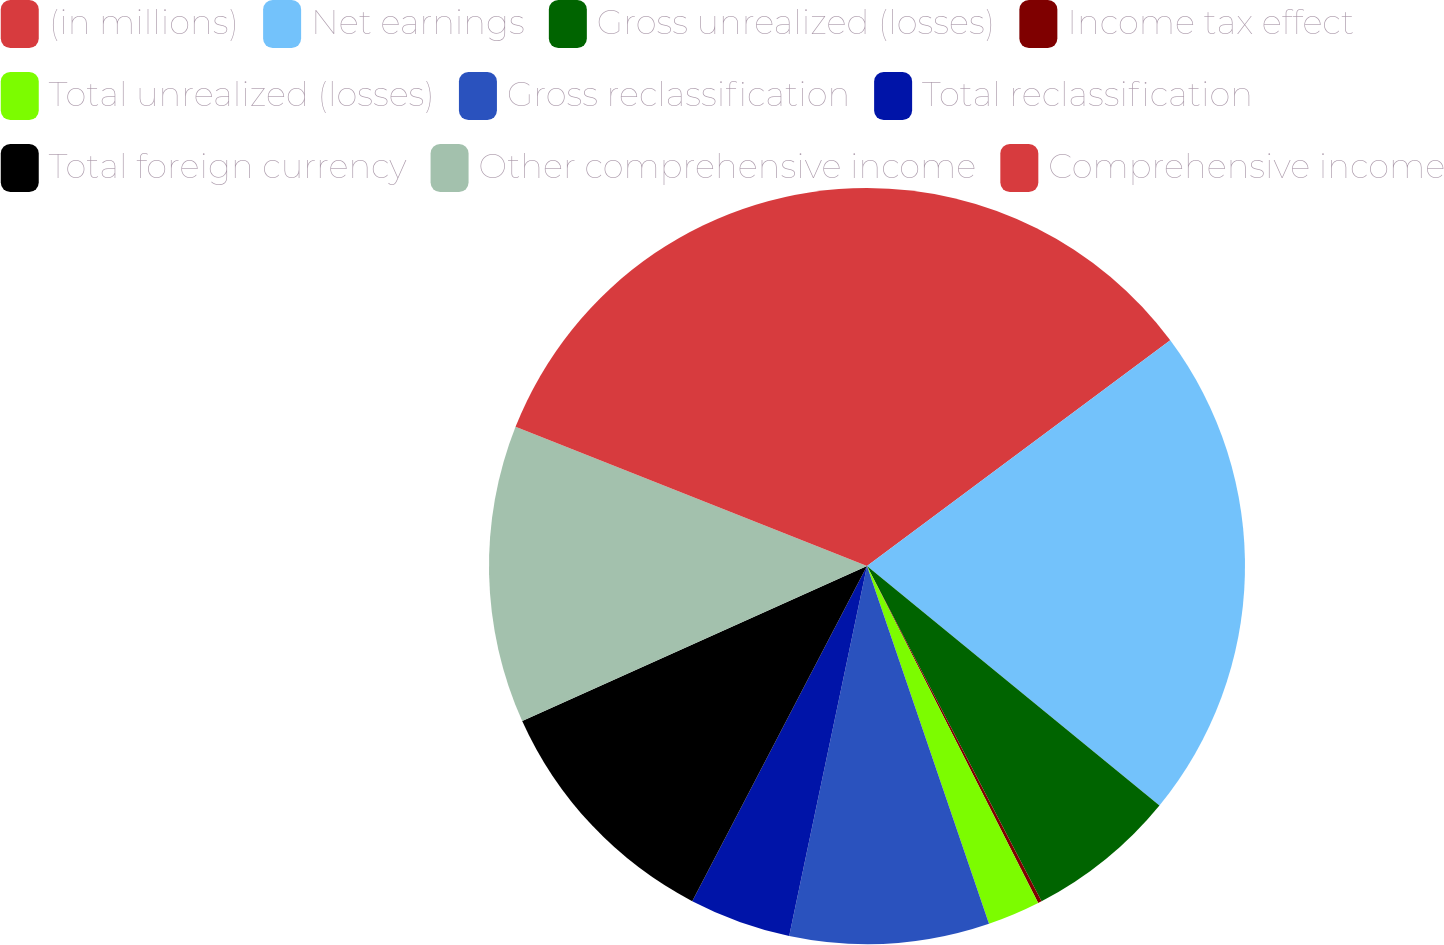Convert chart. <chart><loc_0><loc_0><loc_500><loc_500><pie_chart><fcel>(in millions)<fcel>Net earnings<fcel>Gross unrealized (losses)<fcel>Income tax effect<fcel>Total unrealized (losses)<fcel>Gross reclassification<fcel>Total reclassification<fcel>Total foreign currency<fcel>Other comprehensive income<fcel>Comprehensive income<nl><fcel>14.82%<fcel>21.1%<fcel>6.44%<fcel>0.16%<fcel>2.25%<fcel>8.53%<fcel>4.35%<fcel>10.63%<fcel>12.72%<fcel>19.0%<nl></chart> 